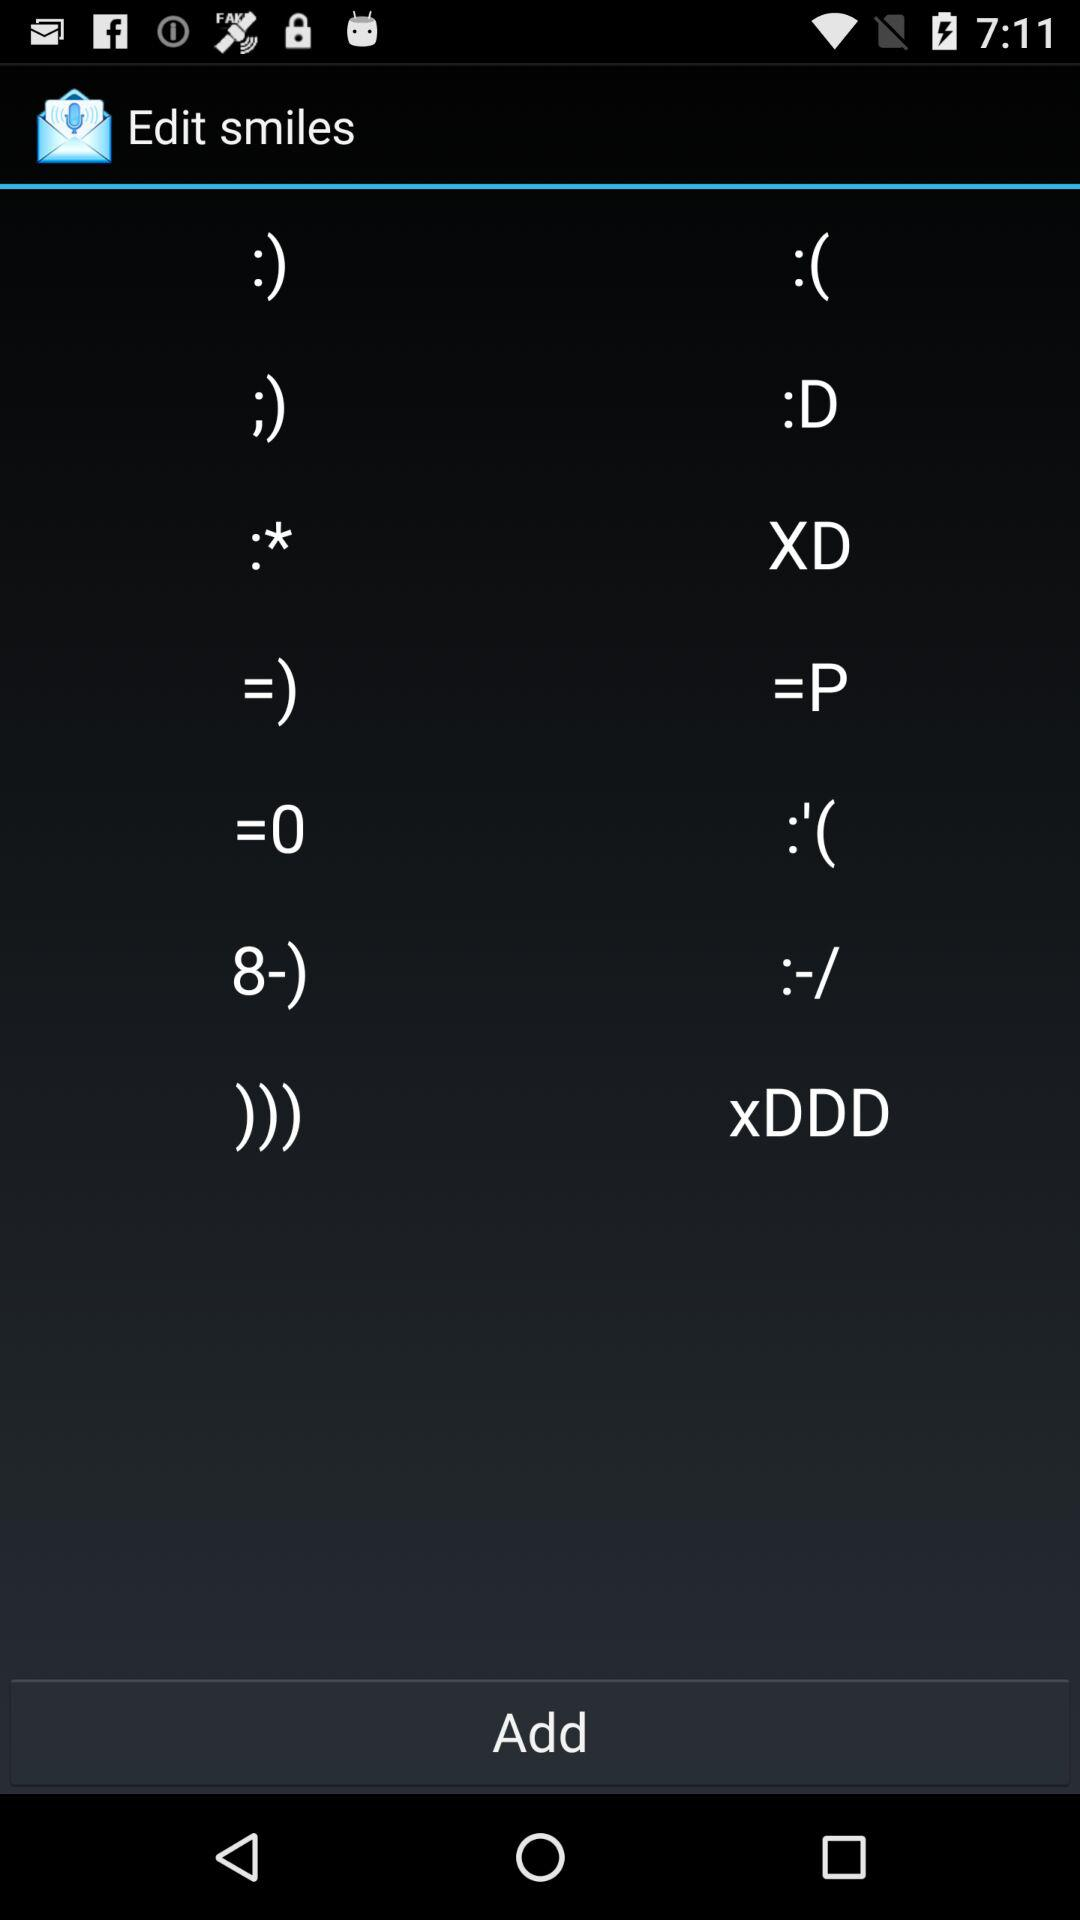What is the name of the application? The name of the application is "Edit smiles". 